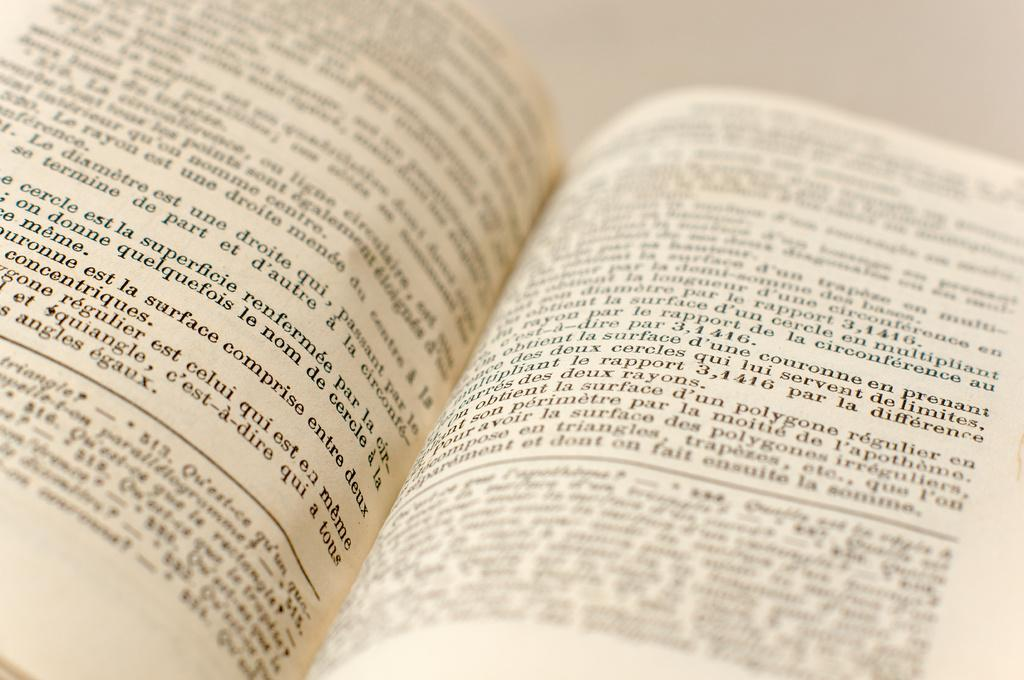Provide a one-sentence caption for the provided image. A book is open to a page that says est la surface comprise entre duex. 